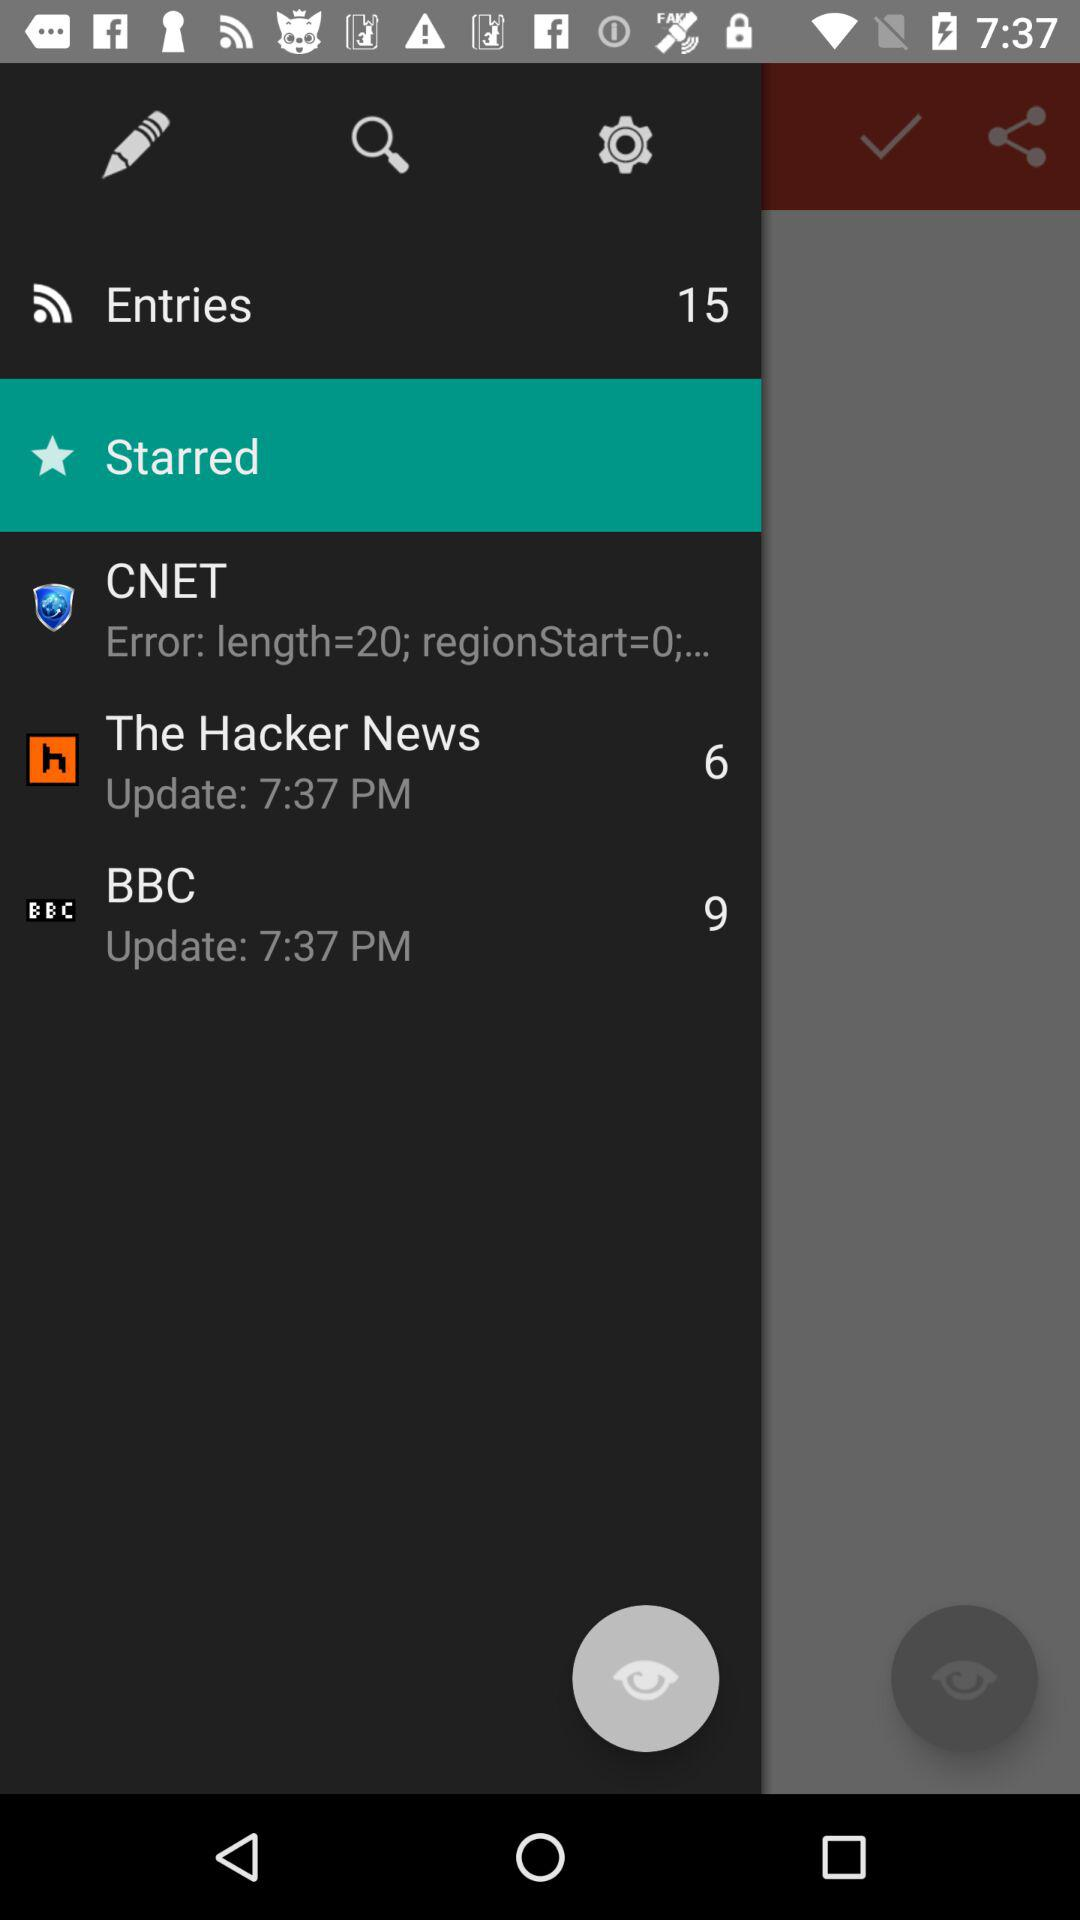What is the total number of news items displayed in "The Hacker News"? The total number of news items displayed in "The Hacker News" is 6. 